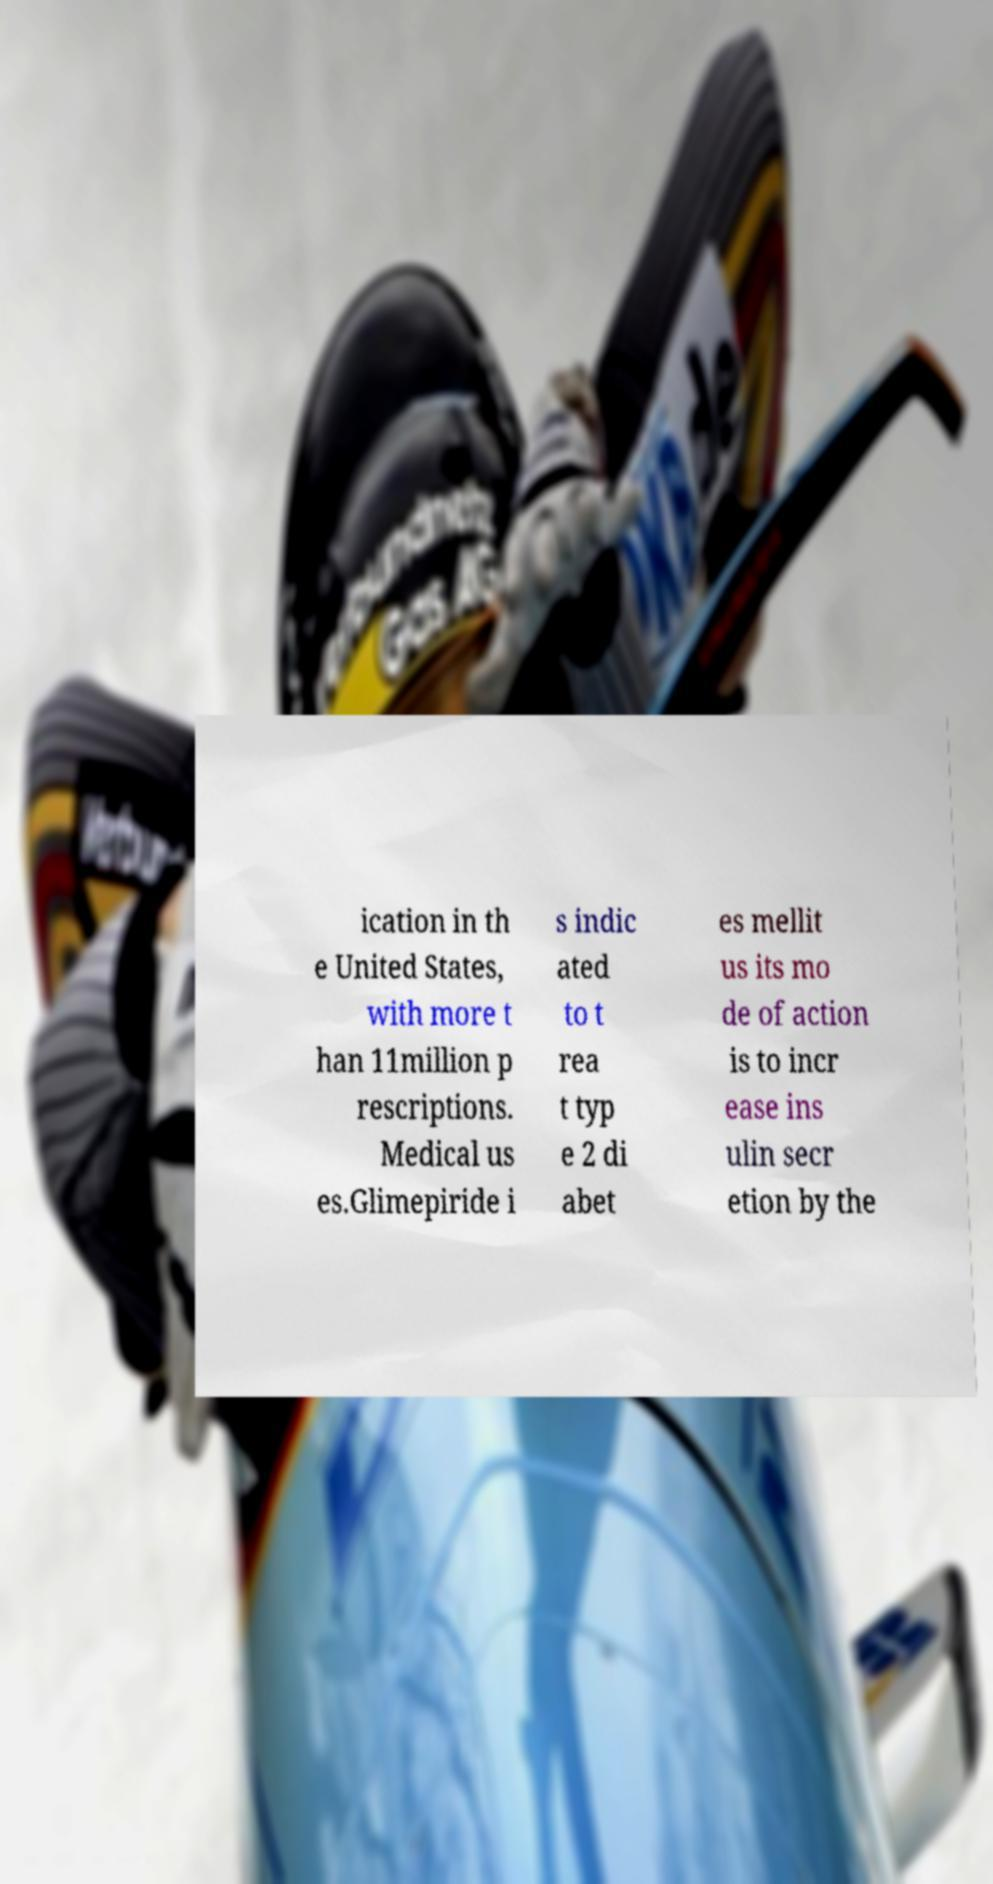Can you accurately transcribe the text from the provided image for me? ication in th e United States, with more t han 11million p rescriptions. Medical us es.Glimepiride i s indic ated to t rea t typ e 2 di abet es mellit us its mo de of action is to incr ease ins ulin secr etion by the 